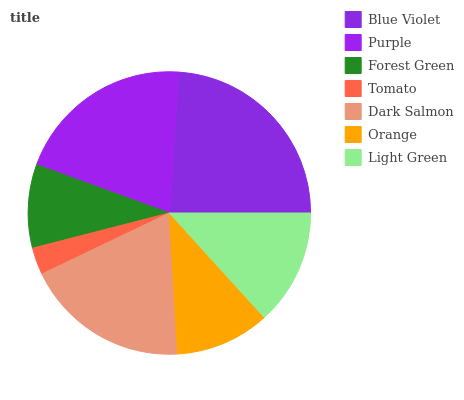Is Tomato the minimum?
Answer yes or no. Yes. Is Blue Violet the maximum?
Answer yes or no. Yes. Is Purple the minimum?
Answer yes or no. No. Is Purple the maximum?
Answer yes or no. No. Is Blue Violet greater than Purple?
Answer yes or no. Yes. Is Purple less than Blue Violet?
Answer yes or no. Yes. Is Purple greater than Blue Violet?
Answer yes or no. No. Is Blue Violet less than Purple?
Answer yes or no. No. Is Light Green the high median?
Answer yes or no. Yes. Is Light Green the low median?
Answer yes or no. Yes. Is Blue Violet the high median?
Answer yes or no. No. Is Orange the low median?
Answer yes or no. No. 